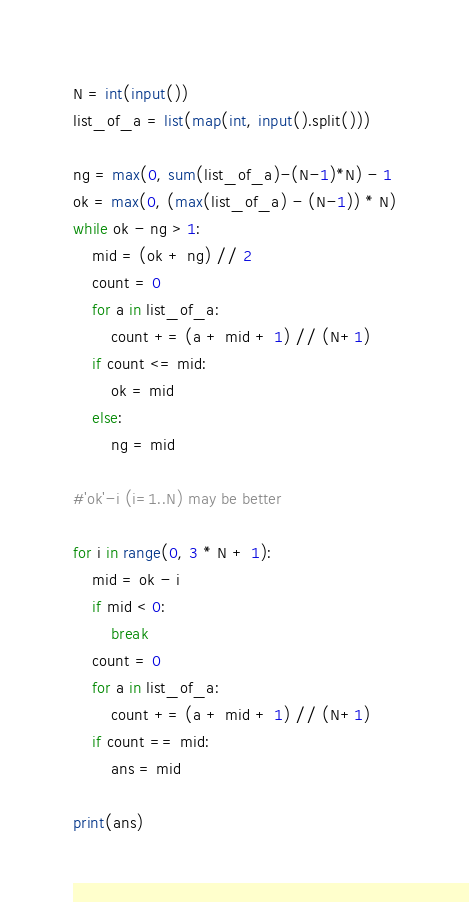<code> <loc_0><loc_0><loc_500><loc_500><_Python_>N = int(input())
list_of_a = list(map(int, input().split()))

ng = max(0, sum(list_of_a)-(N-1)*N) - 1
ok = max(0, (max(list_of_a) - (N-1)) * N)
while ok - ng > 1:
    mid = (ok + ng) // 2
    count = 0
    for a in list_of_a:
        count += (a + mid + 1) // (N+1)
    if count <= mid:
        ok = mid
    else:
        ng = mid

#'ok'-i (i=1..N) may be better

for i in range(0, 3 * N + 1):
    mid = ok - i
    if mid < 0:
        break
    count = 0
    for a in list_of_a:
        count += (a + mid + 1) // (N+1)
    if count == mid:
        ans = mid

print(ans)
</code> 